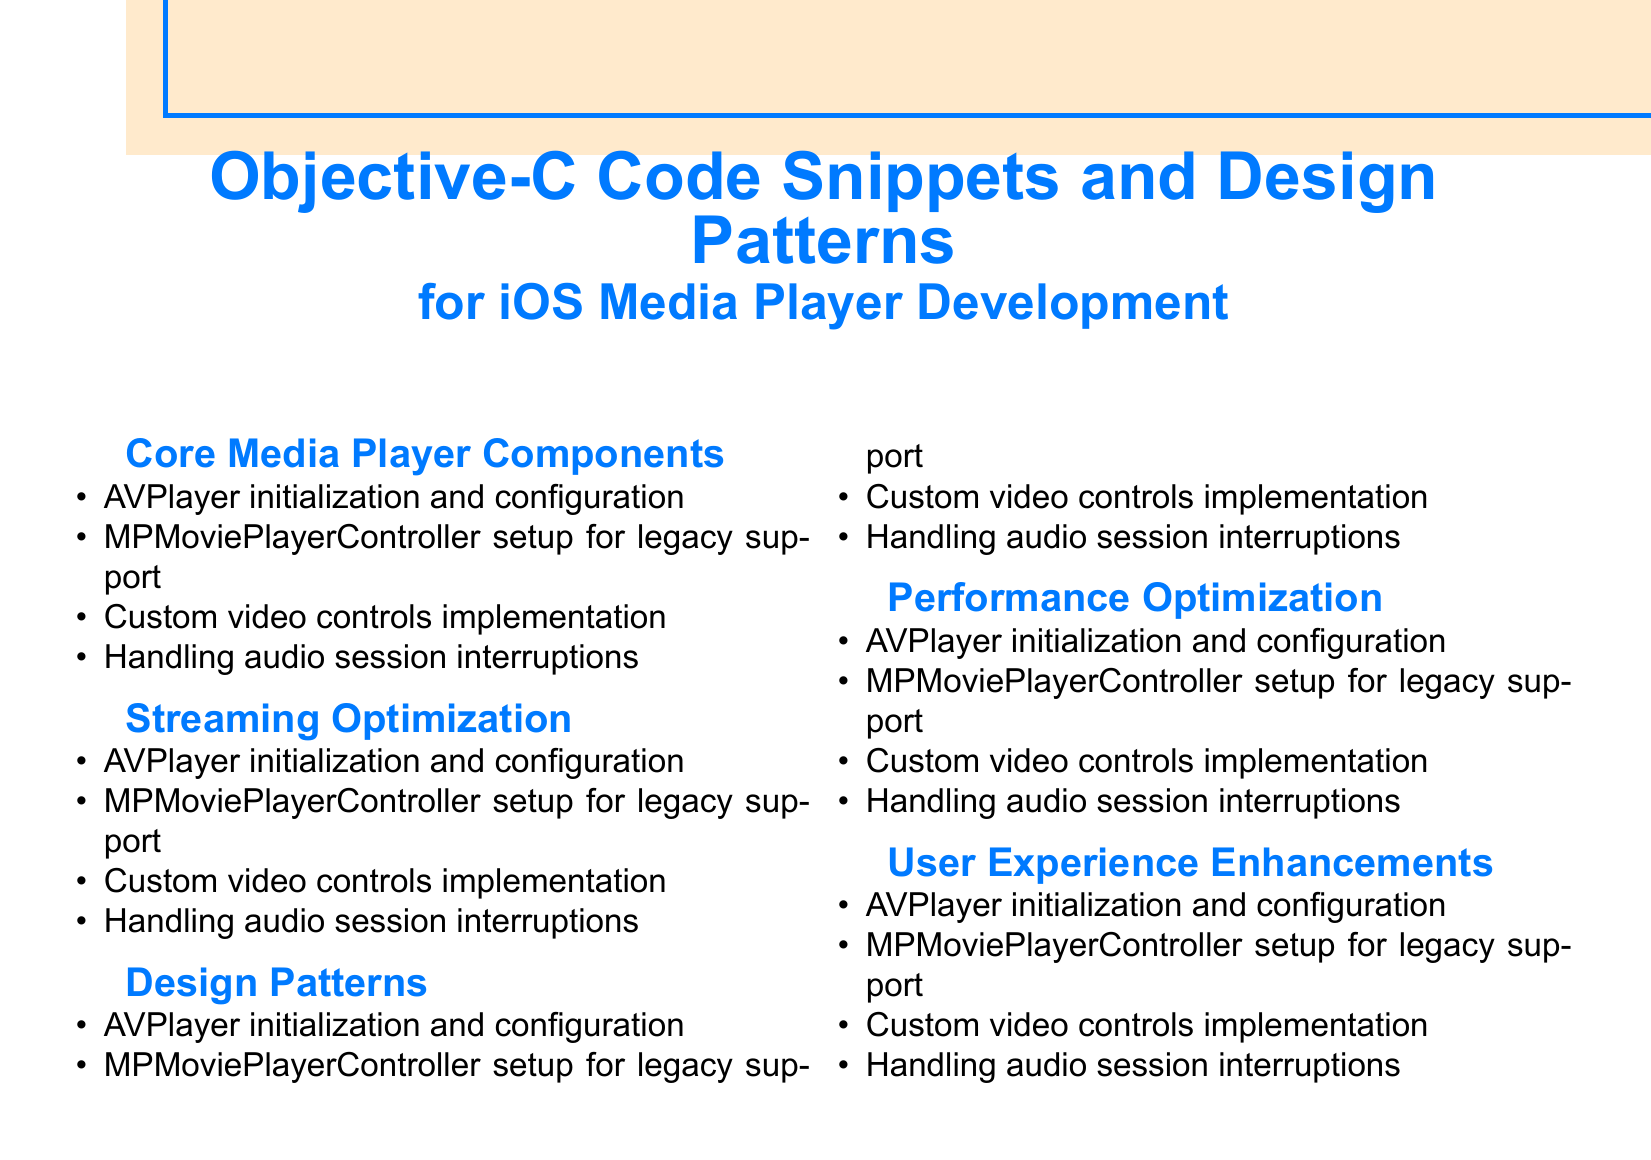What is the main topic of this document? The main topic is the collection of code snippets and design patterns for iOS media player development.
Answer: Objective-C Code Snippets and Design Patterns How many main sections are there in the document? The main sections listed in the document are five in total.
Answer: 5 What design pattern is mentioned for creating media items? The document refers to a specific design pattern used for creating media items.
Answer: Factory method Which media player component is noted for legacy support? The document mentions a specific media player component that provides legacy support.
Answer: MPMoviePlayerController What feature is included for user experience enhancements? Enhancements for user experience in media player applications include a specific feature.
Answer: Picture-in-picture mode Which optimization technique is recommended for streaming? The document outlines a specific technique for optimizing streaming performance.
Answer: Adaptive bitrate streaming What is a key focus in performance optimization? The document highlights an important area to address under performance optimization.
Answer: Battery consumption Which type of recognizers is mentioned for playback control? The document indicates a specific type of recognizer that aids in controlling playback.
Answer: Gesture recognizers 